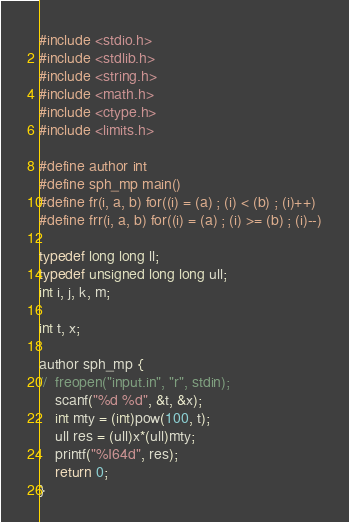Convert code to text. <code><loc_0><loc_0><loc_500><loc_500><_C_>#include <stdio.h>
#include <stdlib.h>
#include <string.h>
#include <math.h>
#include <ctype.h>
#include <limits.h>
 
#define author int
#define sph_mp main() 
#define fr(i, a, b) for((i) = (a) ; (i) < (b) ; (i)++)
#define frr(i, a, b) for((i) = (a) ; (i) >= (b) ; (i)--)
 
typedef long long ll;
typedef unsigned long long ull;
int i, j, k, m;
 
int t, x;
 
author sph_mp {
//	freopen("input.in", "r", stdin);
	scanf("%d %d", &t, &x);
	int mty = (int)pow(100, t);
	ull res = (ull)x*(ull)mty;
    printf("%I64d", res);
	return 0;
}</code> 